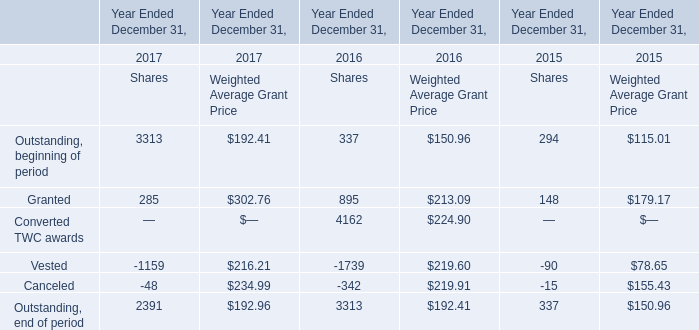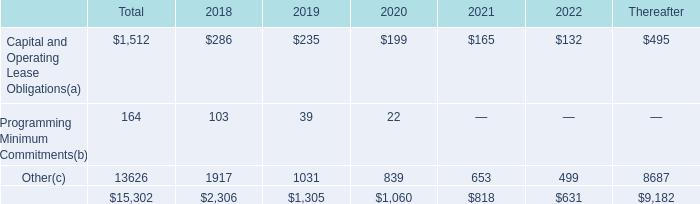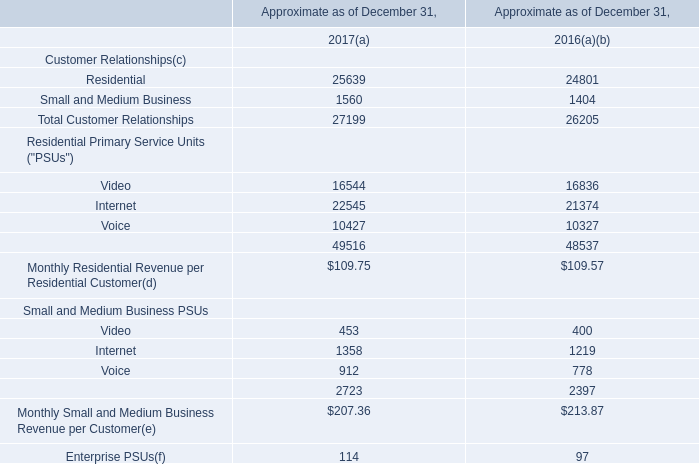What was the total amount of Converted TWC awards at Weighted Average Grant Price in 2016? 
Answer: 224.9. 